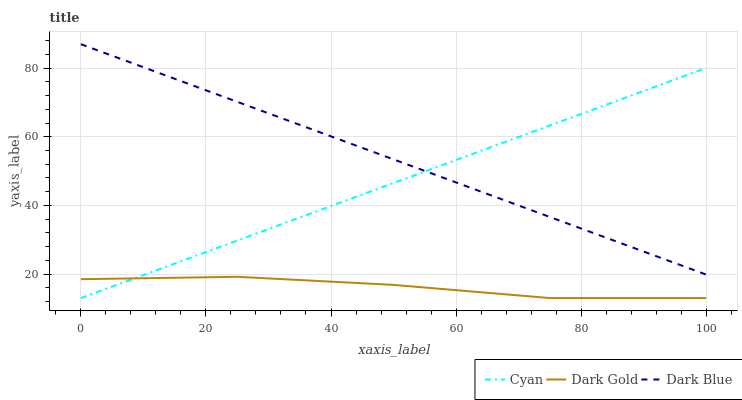Does Dark Gold have the minimum area under the curve?
Answer yes or no. Yes. Does Dark Blue have the minimum area under the curve?
Answer yes or no. No. Does Dark Gold have the maximum area under the curve?
Answer yes or no. No. Is Dark Gold the roughest?
Answer yes or no. Yes. Is Dark Blue the smoothest?
Answer yes or no. No. Is Dark Blue the roughest?
Answer yes or no. No. Does Dark Blue have the lowest value?
Answer yes or no. No. Does Dark Gold have the highest value?
Answer yes or no. No. Is Dark Gold less than Dark Blue?
Answer yes or no. Yes. Is Dark Blue greater than Dark Gold?
Answer yes or no. Yes. Does Dark Gold intersect Dark Blue?
Answer yes or no. No. 